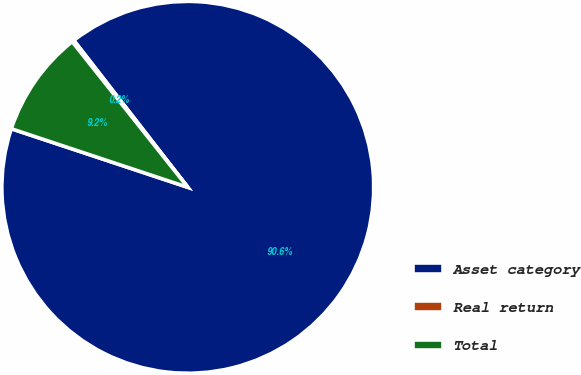Convert chart. <chart><loc_0><loc_0><loc_500><loc_500><pie_chart><fcel>Asset category<fcel>Real return<fcel>Total<nl><fcel>90.6%<fcel>0.18%<fcel>9.22%<nl></chart> 